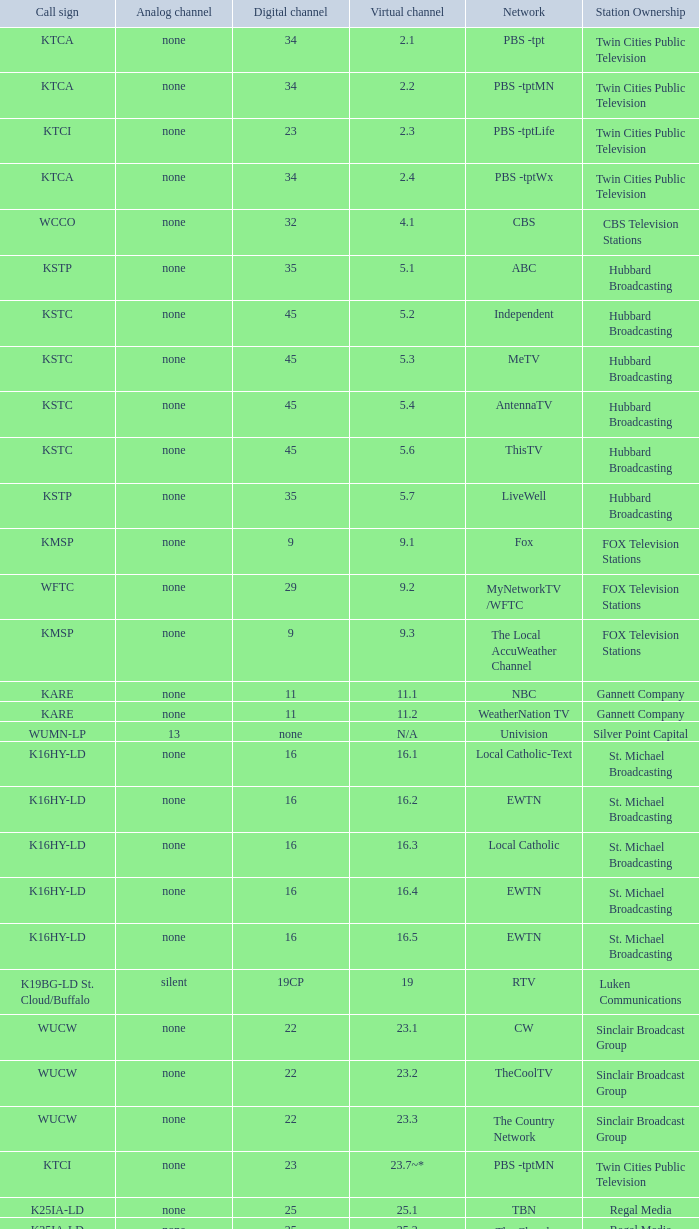What virtual network does station ownership of eicb tv and a call sign of ktcj-ld belong to? 50.1. 